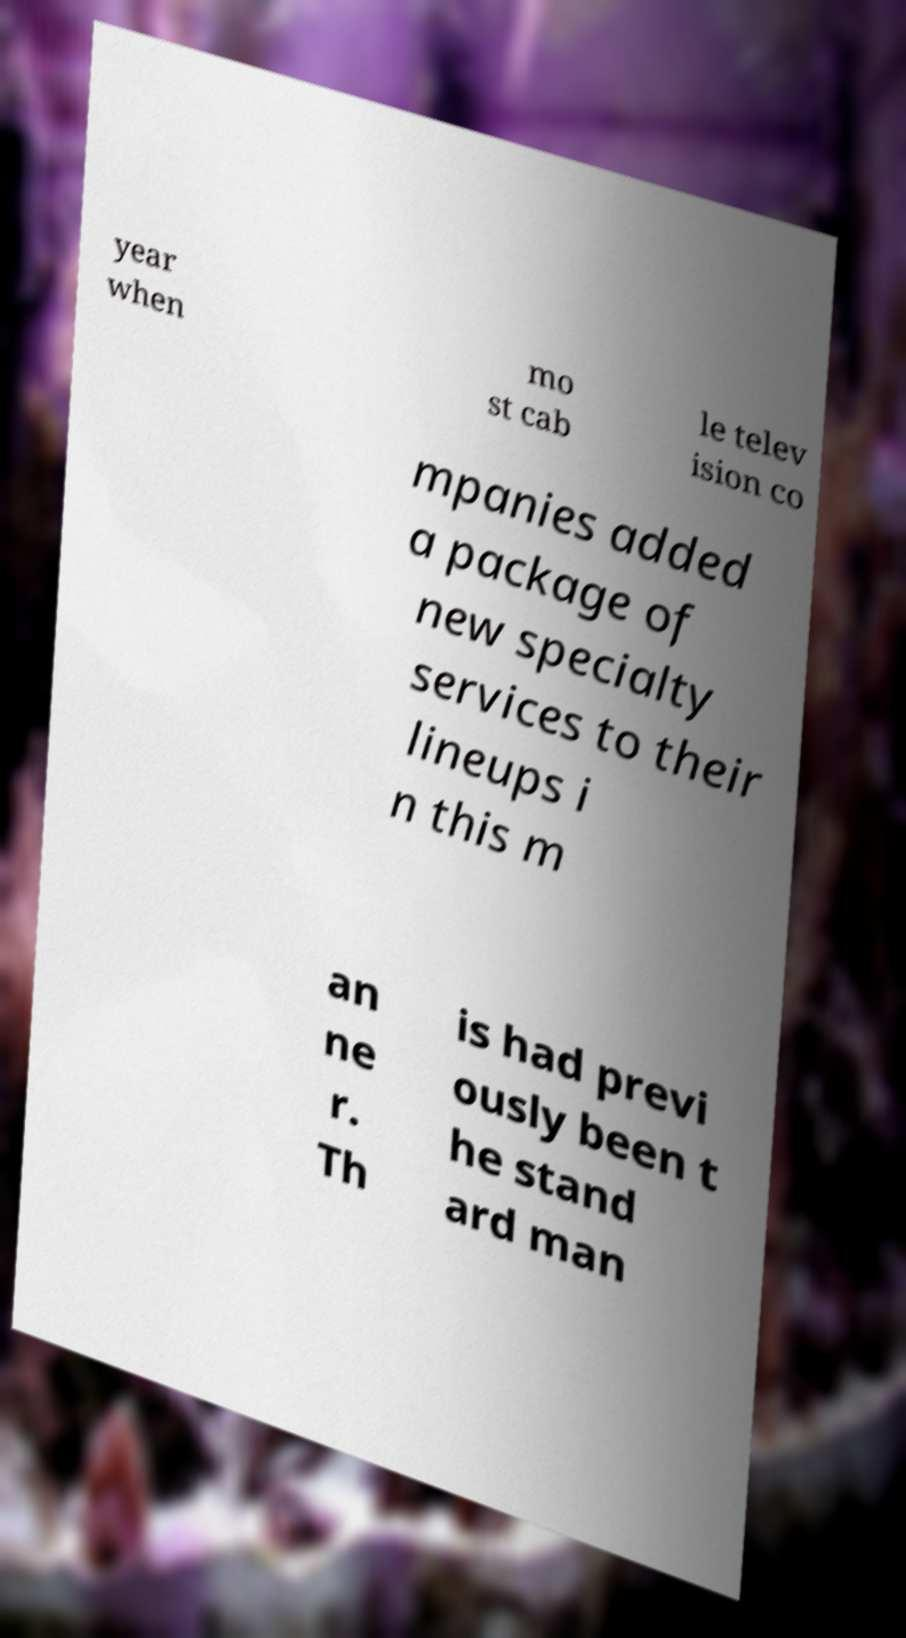What messages or text are displayed in this image? I need them in a readable, typed format. year when mo st cab le telev ision co mpanies added a package of new specialty services to their lineups i n this m an ne r. Th is had previ ously been t he stand ard man 